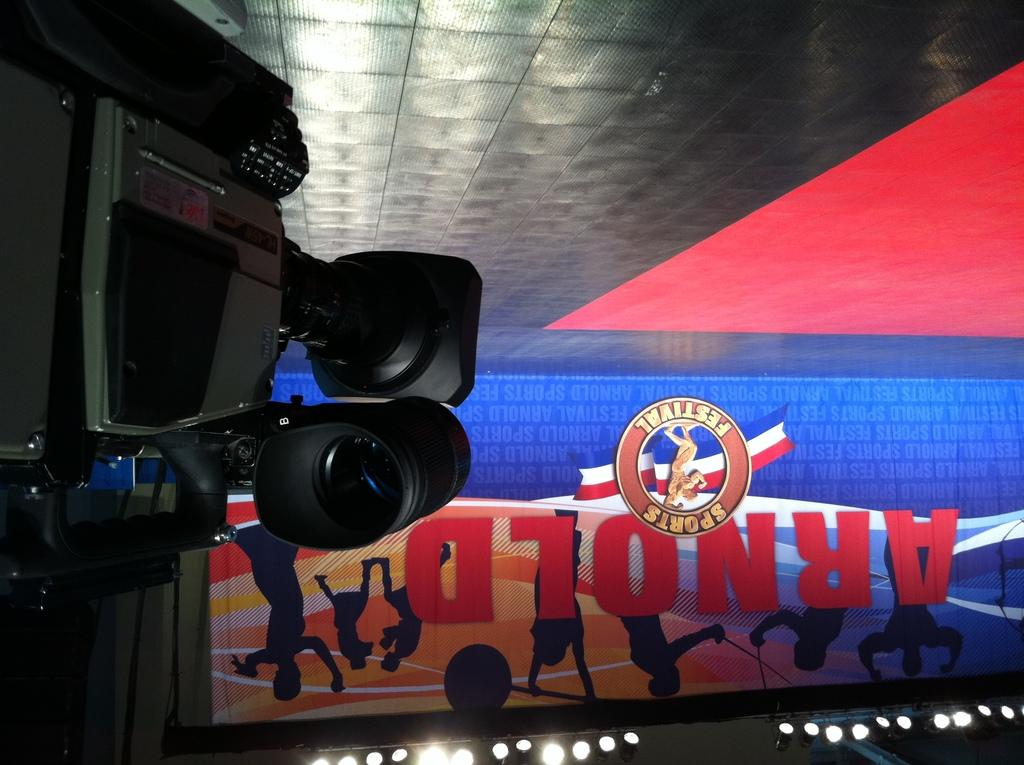What device is present in the image? There is a video camera in the image. What else can be seen in the image besides the video camera? There is a poster in the image. Can you describe the poster? The poster contains text. What else is visible in the image? There are lights visible in the image. What type of oatmeal is being served in the image? There is no oatmeal present in the image. How does the key help in the loss of the video camera in the image? There is no key or loss mentioned in the image, and the video camera is not lost. 